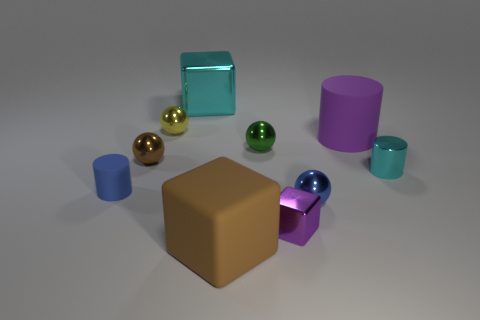Which objects in the image have reflective surfaces? The blue metallic sphere and the smaller golden spheres have reflective surfaces, which can be identified by the light and environment reflections visible on their exteriors.  How many objects share the same geometrical shape as the large brown object in the center? Considering the large brown object in the center is a cube, there are no other objects that share the exact same cube shape in the image. 